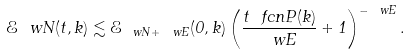<formula> <loc_0><loc_0><loc_500><loc_500>\mathcal { E } _ { \ } w N ( t , k ) \lesssim \mathcal { E } _ { \ w N + \ w E } ( 0 , k ) \left ( \frac { t \ f c n P ( k ) } { \ w E } + 1 \right ) ^ { - \ w E } .</formula> 